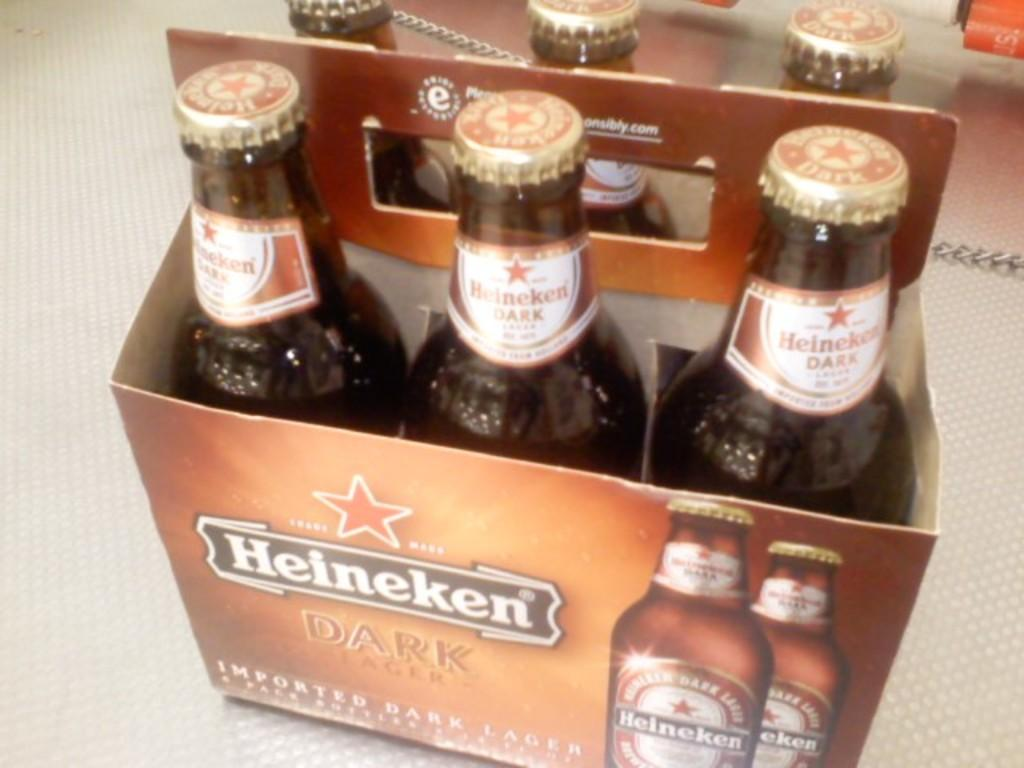<image>
Offer a succinct explanation of the picture presented. A case of heineken sits on a white counter 